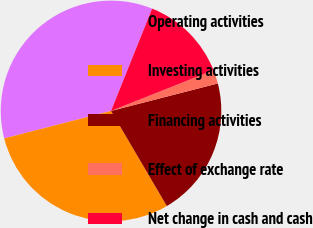Convert chart to OTSL. <chart><loc_0><loc_0><loc_500><loc_500><pie_chart><fcel>Operating activities<fcel>Investing activities<fcel>Financing activities<fcel>Effect of exchange rate<fcel>Net change in cash and cash<nl><fcel>35.09%<fcel>29.44%<fcel>20.56%<fcel>2.01%<fcel>12.9%<nl></chart> 